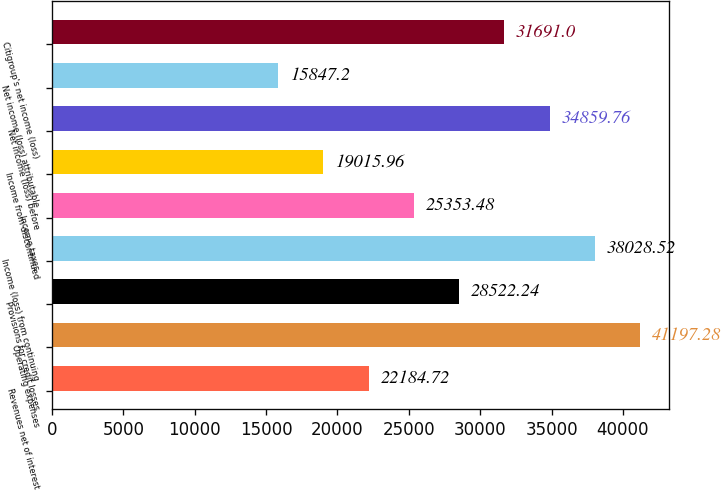Convert chart. <chart><loc_0><loc_0><loc_500><loc_500><bar_chart><fcel>Revenues net of interest<fcel>Operating expenses<fcel>Provisions for credit losses<fcel>Income (loss) from continuing<fcel>Income taxes<fcel>Income from discontinued<fcel>Net income (loss) before<fcel>Net income (loss) attributable<fcel>Citigroup's net income (loss)<nl><fcel>22184.7<fcel>41197.3<fcel>28522.2<fcel>38028.5<fcel>25353.5<fcel>19016<fcel>34859.8<fcel>15847.2<fcel>31691<nl></chart> 